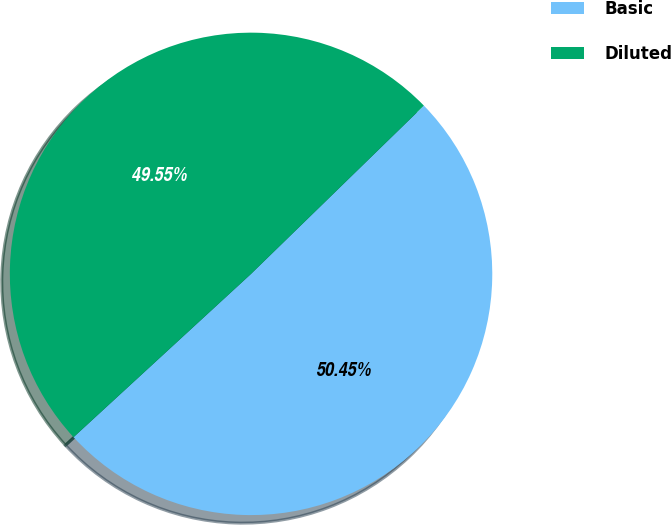Convert chart to OTSL. <chart><loc_0><loc_0><loc_500><loc_500><pie_chart><fcel>Basic<fcel>Diluted<nl><fcel>50.45%<fcel>49.55%<nl></chart> 